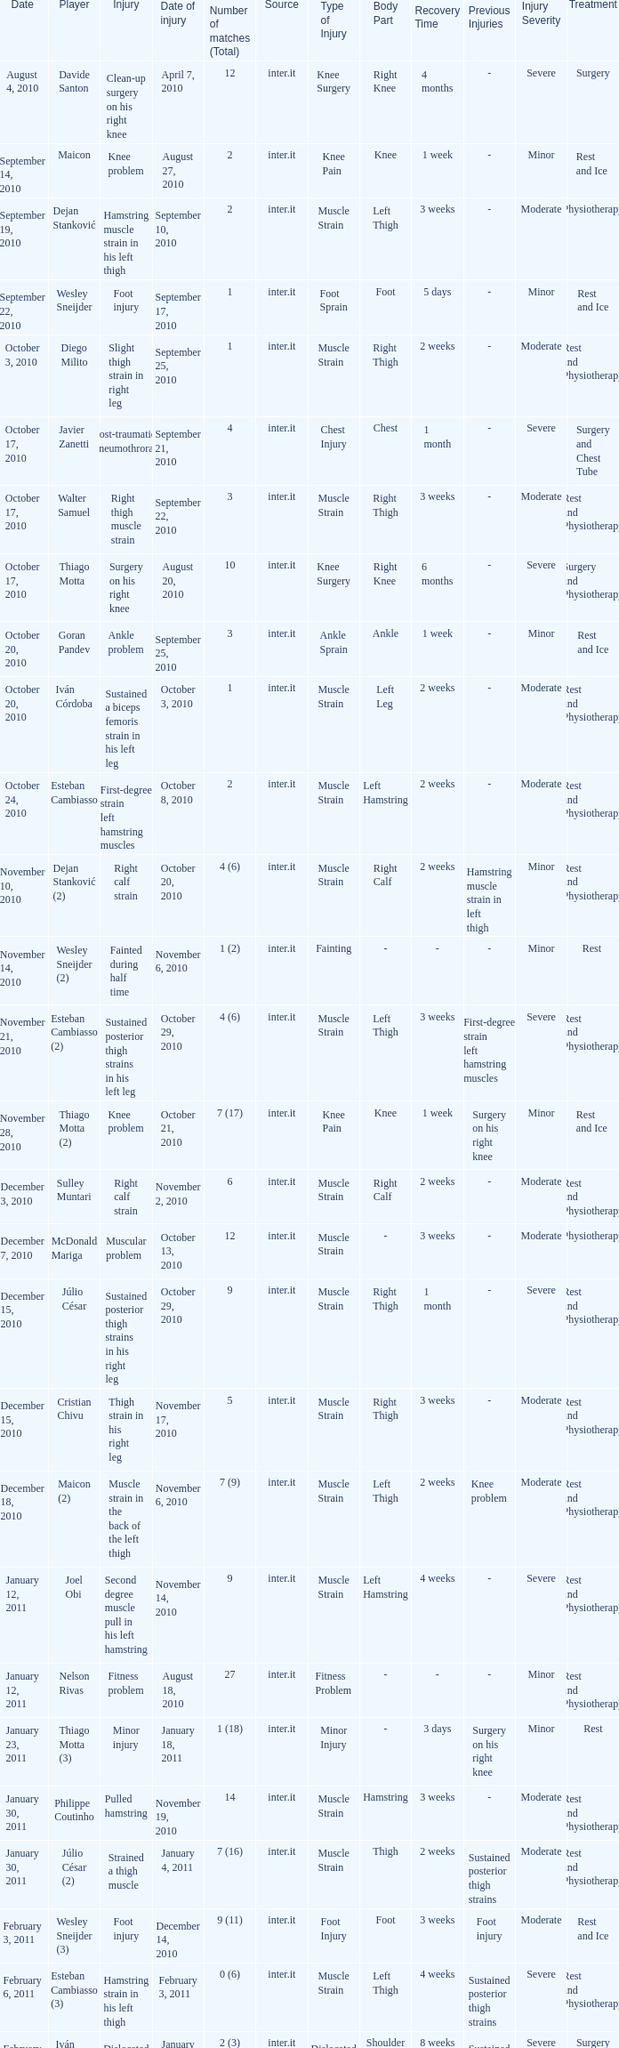What is the date of injury when the injury is sustained posterior thigh strains in his left leg? October 29, 2010. 